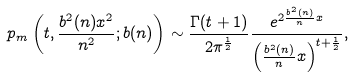Convert formula to latex. <formula><loc_0><loc_0><loc_500><loc_500>p _ { m } \left ( t , \frac { b ^ { 2 } ( n ) x ^ { 2 } } { n ^ { 2 } } ; b ( n ) \right ) \sim \frac { \Gamma ( t + 1 ) } { 2 \pi ^ { \frac { 1 } { 2 } } } \frac { e ^ { 2 \frac { b ^ { 2 } ( n ) } { n } x } } { \left ( \frac { b ^ { 2 } ( n ) } { n } x \right ) ^ { t + \frac { 1 } { 2 } } } ,</formula> 